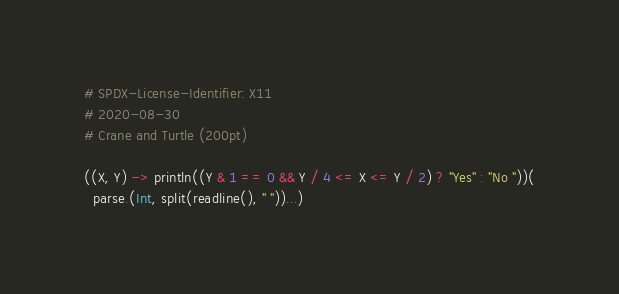Convert code to text. <code><loc_0><loc_0><loc_500><loc_500><_Julia_># SPDX-License-Identifier: X11
# 2020-08-30
# Crane and Turtle (200pt)

((X, Y) -> println((Y & 1 == 0 && Y / 4 <= X <= Y / 2) ? "Yes" : "No "))(
  parse.(Int, split(readline(), " "))...)
</code> 